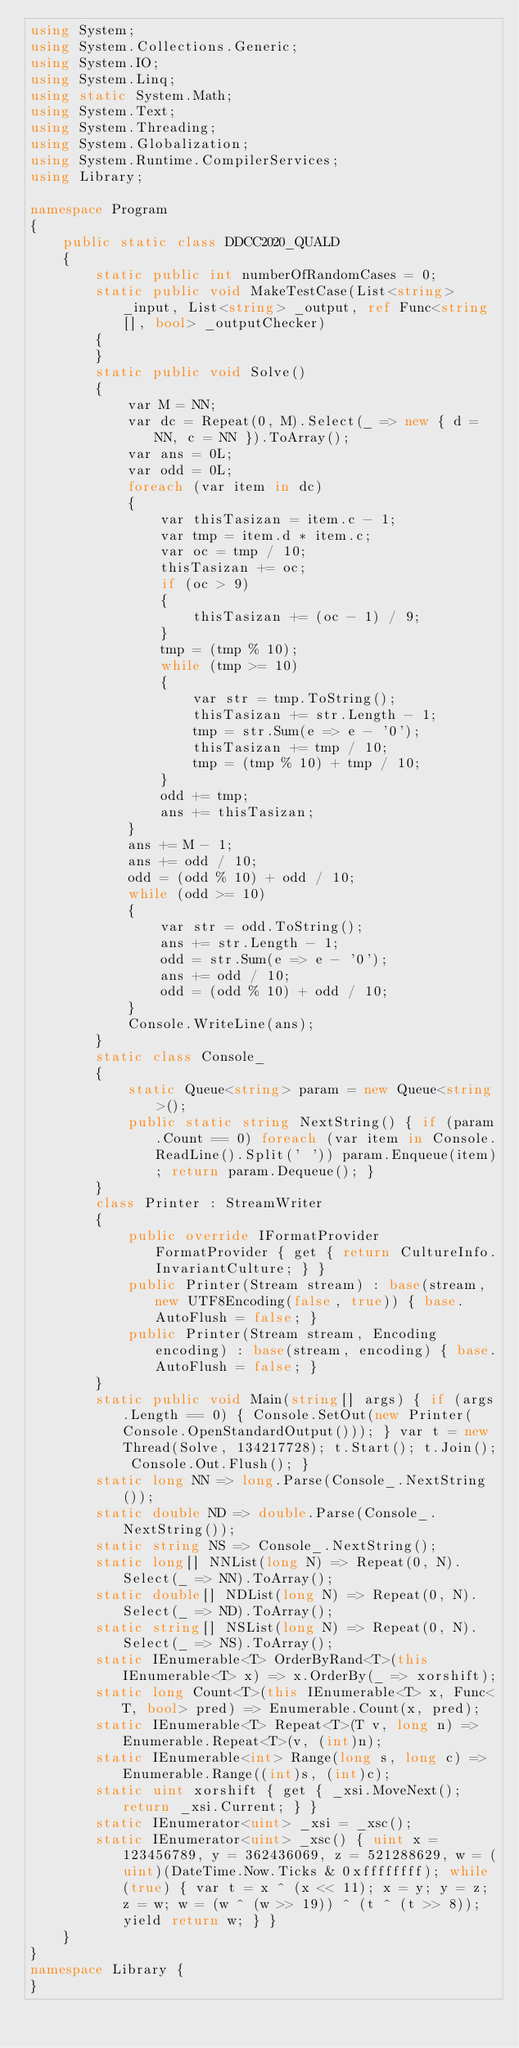Convert code to text. <code><loc_0><loc_0><loc_500><loc_500><_C#_>using System;
using System.Collections.Generic;
using System.IO;
using System.Linq;
using static System.Math;
using System.Text;
using System.Threading;
using System.Globalization;
using System.Runtime.CompilerServices;
using Library;

namespace Program
{
    public static class DDCC2020_QUALD
    {
        static public int numberOfRandomCases = 0;
        static public void MakeTestCase(List<string> _input, List<string> _output, ref Func<string[], bool> _outputChecker)
        {
        }
        static public void Solve()
        {
            var M = NN;
            var dc = Repeat(0, M).Select(_ => new { d = NN, c = NN }).ToArray();
            var ans = 0L;
            var odd = 0L;
            foreach (var item in dc)
            {
                var thisTasizan = item.c - 1;
                var tmp = item.d * item.c;
                var oc = tmp / 10;
                thisTasizan += oc;
                if (oc > 9)
                {
                    thisTasizan += (oc - 1) / 9;
                }
                tmp = (tmp % 10);
                while (tmp >= 10)
                {
                    var str = tmp.ToString();
                    thisTasizan += str.Length - 1;
                    tmp = str.Sum(e => e - '0');
                    thisTasizan += tmp / 10;
                    tmp = (tmp % 10) + tmp / 10;
                }
                odd += tmp;
                ans += thisTasizan;
            }
            ans += M - 1;
            ans += odd / 10;
            odd = (odd % 10) + odd / 10;
            while (odd >= 10)
            {
                var str = odd.ToString();
                ans += str.Length - 1;
                odd = str.Sum(e => e - '0');
                ans += odd / 10;
                odd = (odd % 10) + odd / 10;
            }
            Console.WriteLine(ans);
        }
        static class Console_
        {
            static Queue<string> param = new Queue<string>();
            public static string NextString() { if (param.Count == 0) foreach (var item in Console.ReadLine().Split(' ')) param.Enqueue(item); return param.Dequeue(); }
        }
        class Printer : StreamWriter
        {
            public override IFormatProvider FormatProvider { get { return CultureInfo.InvariantCulture; } }
            public Printer(Stream stream) : base(stream, new UTF8Encoding(false, true)) { base.AutoFlush = false; }
            public Printer(Stream stream, Encoding encoding) : base(stream, encoding) { base.AutoFlush = false; }
        }
        static public void Main(string[] args) { if (args.Length == 0) { Console.SetOut(new Printer(Console.OpenStandardOutput())); } var t = new Thread(Solve, 134217728); t.Start(); t.Join(); Console.Out.Flush(); }
        static long NN => long.Parse(Console_.NextString());
        static double ND => double.Parse(Console_.NextString());
        static string NS => Console_.NextString();
        static long[] NNList(long N) => Repeat(0, N).Select(_ => NN).ToArray();
        static double[] NDList(long N) => Repeat(0, N).Select(_ => ND).ToArray();
        static string[] NSList(long N) => Repeat(0, N).Select(_ => NS).ToArray();
        static IEnumerable<T> OrderByRand<T>(this IEnumerable<T> x) => x.OrderBy(_ => xorshift);
        static long Count<T>(this IEnumerable<T> x, Func<T, bool> pred) => Enumerable.Count(x, pred);
        static IEnumerable<T> Repeat<T>(T v, long n) => Enumerable.Repeat<T>(v, (int)n);
        static IEnumerable<int> Range(long s, long c) => Enumerable.Range((int)s, (int)c);
        static uint xorshift { get { _xsi.MoveNext(); return _xsi.Current; } }
        static IEnumerator<uint> _xsi = _xsc();
        static IEnumerator<uint> _xsc() { uint x = 123456789, y = 362436069, z = 521288629, w = (uint)(DateTime.Now.Ticks & 0xffffffff); while (true) { var t = x ^ (x << 11); x = y; y = z; z = w; w = (w ^ (w >> 19)) ^ (t ^ (t >> 8)); yield return w; } }
    }
}
namespace Library {
}
</code> 